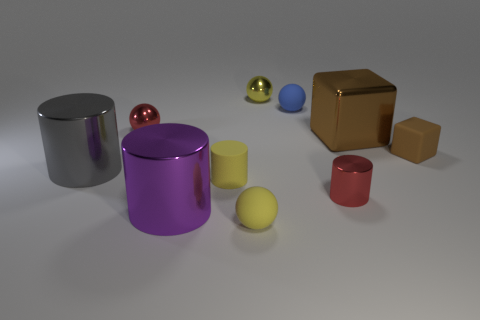The large gray thing is what shape?
Offer a very short reply. Cylinder. Is there any other thing that has the same size as the red metallic sphere?
Ensure brevity in your answer.  Yes. Are there more small brown objects that are left of the blue rubber ball than gray shiny cylinders?
Keep it short and to the point. No. What shape is the small rubber thing that is in front of the tiny metallic object that is in front of the red shiny thing behind the tiny brown thing?
Your answer should be compact. Sphere. There is a matte sphere that is in front of the brown metallic object; is its size the same as the yellow cylinder?
Offer a very short reply. Yes. There is a big object that is both behind the big purple metal thing and on the right side of the big gray shiny thing; what shape is it?
Provide a short and direct response. Cube. Is the color of the matte cylinder the same as the tiny object on the right side of the brown metal object?
Your response must be concise. No. What color is the large metallic cylinder left of the tiny shiny object left of the yellow sphere that is behind the big purple shiny cylinder?
Ensure brevity in your answer.  Gray. There is another big shiny object that is the same shape as the big gray metallic thing; what color is it?
Ensure brevity in your answer.  Purple. Are there an equal number of big cylinders right of the brown metal block and red metallic cylinders?
Provide a succinct answer. No. 